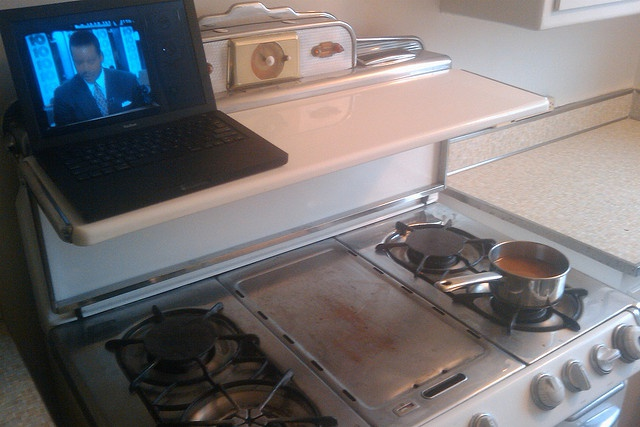Describe the objects in this image and their specific colors. I can see oven in gray, black, darkgray, and lightgray tones and laptop in gray, black, navy, lightblue, and blue tones in this image. 